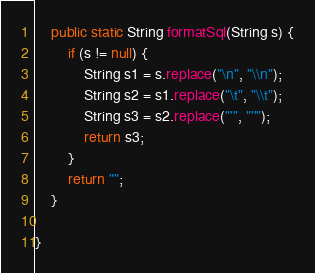Convert code to text. <code><loc_0><loc_0><loc_500><loc_500><_Java_>
	public static String formatSql(String s) {
		if (s != null) {
			String s1 = s.replace("\n", "\\n");
			String s2 = s1.replace("\t", "\\t");
			String s3 = s2.replace("'", "''");
			return s3;
		}
		return "";
	}

}
</code> 